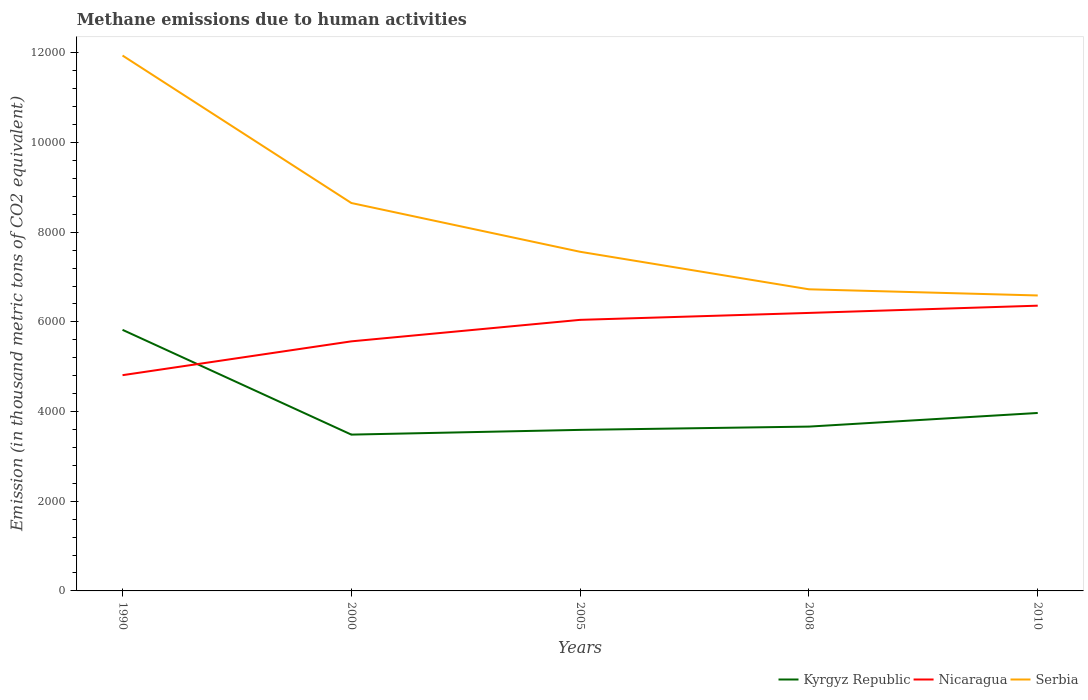How many different coloured lines are there?
Offer a very short reply. 3. Does the line corresponding to Nicaragua intersect with the line corresponding to Kyrgyz Republic?
Give a very brief answer. Yes. Across all years, what is the maximum amount of methane emitted in Nicaragua?
Provide a succinct answer. 4811.3. In which year was the amount of methane emitted in Serbia maximum?
Provide a succinct answer. 2010. What is the total amount of methane emitted in Serbia in the graph?
Your answer should be very brief. 836.6. What is the difference between the highest and the second highest amount of methane emitted in Nicaragua?
Your answer should be compact. 1550.1. What is the difference between the highest and the lowest amount of methane emitted in Nicaragua?
Provide a short and direct response. 3. How many years are there in the graph?
Your response must be concise. 5. Does the graph contain any zero values?
Your answer should be compact. No. Does the graph contain grids?
Your answer should be very brief. No. How many legend labels are there?
Your response must be concise. 3. What is the title of the graph?
Keep it short and to the point. Methane emissions due to human activities. What is the label or title of the X-axis?
Your answer should be very brief. Years. What is the label or title of the Y-axis?
Make the answer very short. Emission (in thousand metric tons of CO2 equivalent). What is the Emission (in thousand metric tons of CO2 equivalent) in Kyrgyz Republic in 1990?
Keep it short and to the point. 5822.6. What is the Emission (in thousand metric tons of CO2 equivalent) of Nicaragua in 1990?
Make the answer very short. 4811.3. What is the Emission (in thousand metric tons of CO2 equivalent) of Serbia in 1990?
Make the answer very short. 1.19e+04. What is the Emission (in thousand metric tons of CO2 equivalent) of Kyrgyz Republic in 2000?
Your answer should be compact. 3485.8. What is the Emission (in thousand metric tons of CO2 equivalent) in Nicaragua in 2000?
Give a very brief answer. 5565.7. What is the Emission (in thousand metric tons of CO2 equivalent) of Serbia in 2000?
Ensure brevity in your answer.  8650.9. What is the Emission (in thousand metric tons of CO2 equivalent) of Kyrgyz Republic in 2005?
Keep it short and to the point. 3591.3. What is the Emission (in thousand metric tons of CO2 equivalent) in Nicaragua in 2005?
Your answer should be very brief. 6045. What is the Emission (in thousand metric tons of CO2 equivalent) in Serbia in 2005?
Your response must be concise. 7563. What is the Emission (in thousand metric tons of CO2 equivalent) in Kyrgyz Republic in 2008?
Keep it short and to the point. 3664.5. What is the Emission (in thousand metric tons of CO2 equivalent) of Nicaragua in 2008?
Ensure brevity in your answer.  6199.5. What is the Emission (in thousand metric tons of CO2 equivalent) in Serbia in 2008?
Your answer should be very brief. 6726.4. What is the Emission (in thousand metric tons of CO2 equivalent) in Kyrgyz Republic in 2010?
Offer a very short reply. 3968.4. What is the Emission (in thousand metric tons of CO2 equivalent) of Nicaragua in 2010?
Give a very brief answer. 6361.4. What is the Emission (in thousand metric tons of CO2 equivalent) of Serbia in 2010?
Your answer should be very brief. 6589. Across all years, what is the maximum Emission (in thousand metric tons of CO2 equivalent) in Kyrgyz Republic?
Provide a short and direct response. 5822.6. Across all years, what is the maximum Emission (in thousand metric tons of CO2 equivalent) of Nicaragua?
Your answer should be very brief. 6361.4. Across all years, what is the maximum Emission (in thousand metric tons of CO2 equivalent) in Serbia?
Keep it short and to the point. 1.19e+04. Across all years, what is the minimum Emission (in thousand metric tons of CO2 equivalent) in Kyrgyz Republic?
Your response must be concise. 3485.8. Across all years, what is the minimum Emission (in thousand metric tons of CO2 equivalent) in Nicaragua?
Offer a very short reply. 4811.3. Across all years, what is the minimum Emission (in thousand metric tons of CO2 equivalent) of Serbia?
Make the answer very short. 6589. What is the total Emission (in thousand metric tons of CO2 equivalent) in Kyrgyz Republic in the graph?
Provide a short and direct response. 2.05e+04. What is the total Emission (in thousand metric tons of CO2 equivalent) of Nicaragua in the graph?
Your response must be concise. 2.90e+04. What is the total Emission (in thousand metric tons of CO2 equivalent) in Serbia in the graph?
Offer a terse response. 4.15e+04. What is the difference between the Emission (in thousand metric tons of CO2 equivalent) of Kyrgyz Republic in 1990 and that in 2000?
Provide a succinct answer. 2336.8. What is the difference between the Emission (in thousand metric tons of CO2 equivalent) in Nicaragua in 1990 and that in 2000?
Provide a short and direct response. -754.4. What is the difference between the Emission (in thousand metric tons of CO2 equivalent) of Serbia in 1990 and that in 2000?
Your response must be concise. 3288.8. What is the difference between the Emission (in thousand metric tons of CO2 equivalent) of Kyrgyz Republic in 1990 and that in 2005?
Your response must be concise. 2231.3. What is the difference between the Emission (in thousand metric tons of CO2 equivalent) of Nicaragua in 1990 and that in 2005?
Ensure brevity in your answer.  -1233.7. What is the difference between the Emission (in thousand metric tons of CO2 equivalent) in Serbia in 1990 and that in 2005?
Ensure brevity in your answer.  4376.7. What is the difference between the Emission (in thousand metric tons of CO2 equivalent) in Kyrgyz Republic in 1990 and that in 2008?
Your response must be concise. 2158.1. What is the difference between the Emission (in thousand metric tons of CO2 equivalent) of Nicaragua in 1990 and that in 2008?
Offer a terse response. -1388.2. What is the difference between the Emission (in thousand metric tons of CO2 equivalent) of Serbia in 1990 and that in 2008?
Offer a terse response. 5213.3. What is the difference between the Emission (in thousand metric tons of CO2 equivalent) of Kyrgyz Republic in 1990 and that in 2010?
Keep it short and to the point. 1854.2. What is the difference between the Emission (in thousand metric tons of CO2 equivalent) in Nicaragua in 1990 and that in 2010?
Provide a short and direct response. -1550.1. What is the difference between the Emission (in thousand metric tons of CO2 equivalent) of Serbia in 1990 and that in 2010?
Keep it short and to the point. 5350.7. What is the difference between the Emission (in thousand metric tons of CO2 equivalent) of Kyrgyz Republic in 2000 and that in 2005?
Offer a terse response. -105.5. What is the difference between the Emission (in thousand metric tons of CO2 equivalent) in Nicaragua in 2000 and that in 2005?
Keep it short and to the point. -479.3. What is the difference between the Emission (in thousand metric tons of CO2 equivalent) of Serbia in 2000 and that in 2005?
Your answer should be compact. 1087.9. What is the difference between the Emission (in thousand metric tons of CO2 equivalent) of Kyrgyz Republic in 2000 and that in 2008?
Offer a terse response. -178.7. What is the difference between the Emission (in thousand metric tons of CO2 equivalent) in Nicaragua in 2000 and that in 2008?
Offer a very short reply. -633.8. What is the difference between the Emission (in thousand metric tons of CO2 equivalent) of Serbia in 2000 and that in 2008?
Make the answer very short. 1924.5. What is the difference between the Emission (in thousand metric tons of CO2 equivalent) in Kyrgyz Republic in 2000 and that in 2010?
Keep it short and to the point. -482.6. What is the difference between the Emission (in thousand metric tons of CO2 equivalent) of Nicaragua in 2000 and that in 2010?
Your answer should be compact. -795.7. What is the difference between the Emission (in thousand metric tons of CO2 equivalent) in Serbia in 2000 and that in 2010?
Provide a succinct answer. 2061.9. What is the difference between the Emission (in thousand metric tons of CO2 equivalent) in Kyrgyz Republic in 2005 and that in 2008?
Provide a short and direct response. -73.2. What is the difference between the Emission (in thousand metric tons of CO2 equivalent) of Nicaragua in 2005 and that in 2008?
Your answer should be very brief. -154.5. What is the difference between the Emission (in thousand metric tons of CO2 equivalent) of Serbia in 2005 and that in 2008?
Provide a short and direct response. 836.6. What is the difference between the Emission (in thousand metric tons of CO2 equivalent) of Kyrgyz Republic in 2005 and that in 2010?
Provide a succinct answer. -377.1. What is the difference between the Emission (in thousand metric tons of CO2 equivalent) in Nicaragua in 2005 and that in 2010?
Give a very brief answer. -316.4. What is the difference between the Emission (in thousand metric tons of CO2 equivalent) of Serbia in 2005 and that in 2010?
Make the answer very short. 974. What is the difference between the Emission (in thousand metric tons of CO2 equivalent) in Kyrgyz Republic in 2008 and that in 2010?
Offer a terse response. -303.9. What is the difference between the Emission (in thousand metric tons of CO2 equivalent) in Nicaragua in 2008 and that in 2010?
Make the answer very short. -161.9. What is the difference between the Emission (in thousand metric tons of CO2 equivalent) in Serbia in 2008 and that in 2010?
Make the answer very short. 137.4. What is the difference between the Emission (in thousand metric tons of CO2 equivalent) in Kyrgyz Republic in 1990 and the Emission (in thousand metric tons of CO2 equivalent) in Nicaragua in 2000?
Offer a terse response. 256.9. What is the difference between the Emission (in thousand metric tons of CO2 equivalent) in Kyrgyz Republic in 1990 and the Emission (in thousand metric tons of CO2 equivalent) in Serbia in 2000?
Offer a very short reply. -2828.3. What is the difference between the Emission (in thousand metric tons of CO2 equivalent) of Nicaragua in 1990 and the Emission (in thousand metric tons of CO2 equivalent) of Serbia in 2000?
Your answer should be compact. -3839.6. What is the difference between the Emission (in thousand metric tons of CO2 equivalent) in Kyrgyz Republic in 1990 and the Emission (in thousand metric tons of CO2 equivalent) in Nicaragua in 2005?
Provide a succinct answer. -222.4. What is the difference between the Emission (in thousand metric tons of CO2 equivalent) in Kyrgyz Republic in 1990 and the Emission (in thousand metric tons of CO2 equivalent) in Serbia in 2005?
Make the answer very short. -1740.4. What is the difference between the Emission (in thousand metric tons of CO2 equivalent) in Nicaragua in 1990 and the Emission (in thousand metric tons of CO2 equivalent) in Serbia in 2005?
Make the answer very short. -2751.7. What is the difference between the Emission (in thousand metric tons of CO2 equivalent) of Kyrgyz Republic in 1990 and the Emission (in thousand metric tons of CO2 equivalent) of Nicaragua in 2008?
Your answer should be very brief. -376.9. What is the difference between the Emission (in thousand metric tons of CO2 equivalent) of Kyrgyz Republic in 1990 and the Emission (in thousand metric tons of CO2 equivalent) of Serbia in 2008?
Make the answer very short. -903.8. What is the difference between the Emission (in thousand metric tons of CO2 equivalent) in Nicaragua in 1990 and the Emission (in thousand metric tons of CO2 equivalent) in Serbia in 2008?
Your response must be concise. -1915.1. What is the difference between the Emission (in thousand metric tons of CO2 equivalent) of Kyrgyz Republic in 1990 and the Emission (in thousand metric tons of CO2 equivalent) of Nicaragua in 2010?
Your answer should be compact. -538.8. What is the difference between the Emission (in thousand metric tons of CO2 equivalent) in Kyrgyz Republic in 1990 and the Emission (in thousand metric tons of CO2 equivalent) in Serbia in 2010?
Make the answer very short. -766.4. What is the difference between the Emission (in thousand metric tons of CO2 equivalent) of Nicaragua in 1990 and the Emission (in thousand metric tons of CO2 equivalent) of Serbia in 2010?
Offer a terse response. -1777.7. What is the difference between the Emission (in thousand metric tons of CO2 equivalent) in Kyrgyz Republic in 2000 and the Emission (in thousand metric tons of CO2 equivalent) in Nicaragua in 2005?
Provide a succinct answer. -2559.2. What is the difference between the Emission (in thousand metric tons of CO2 equivalent) of Kyrgyz Republic in 2000 and the Emission (in thousand metric tons of CO2 equivalent) of Serbia in 2005?
Your response must be concise. -4077.2. What is the difference between the Emission (in thousand metric tons of CO2 equivalent) in Nicaragua in 2000 and the Emission (in thousand metric tons of CO2 equivalent) in Serbia in 2005?
Your response must be concise. -1997.3. What is the difference between the Emission (in thousand metric tons of CO2 equivalent) of Kyrgyz Republic in 2000 and the Emission (in thousand metric tons of CO2 equivalent) of Nicaragua in 2008?
Keep it short and to the point. -2713.7. What is the difference between the Emission (in thousand metric tons of CO2 equivalent) of Kyrgyz Republic in 2000 and the Emission (in thousand metric tons of CO2 equivalent) of Serbia in 2008?
Provide a succinct answer. -3240.6. What is the difference between the Emission (in thousand metric tons of CO2 equivalent) of Nicaragua in 2000 and the Emission (in thousand metric tons of CO2 equivalent) of Serbia in 2008?
Keep it short and to the point. -1160.7. What is the difference between the Emission (in thousand metric tons of CO2 equivalent) in Kyrgyz Republic in 2000 and the Emission (in thousand metric tons of CO2 equivalent) in Nicaragua in 2010?
Your answer should be compact. -2875.6. What is the difference between the Emission (in thousand metric tons of CO2 equivalent) of Kyrgyz Republic in 2000 and the Emission (in thousand metric tons of CO2 equivalent) of Serbia in 2010?
Give a very brief answer. -3103.2. What is the difference between the Emission (in thousand metric tons of CO2 equivalent) of Nicaragua in 2000 and the Emission (in thousand metric tons of CO2 equivalent) of Serbia in 2010?
Your answer should be very brief. -1023.3. What is the difference between the Emission (in thousand metric tons of CO2 equivalent) of Kyrgyz Republic in 2005 and the Emission (in thousand metric tons of CO2 equivalent) of Nicaragua in 2008?
Offer a very short reply. -2608.2. What is the difference between the Emission (in thousand metric tons of CO2 equivalent) in Kyrgyz Republic in 2005 and the Emission (in thousand metric tons of CO2 equivalent) in Serbia in 2008?
Ensure brevity in your answer.  -3135.1. What is the difference between the Emission (in thousand metric tons of CO2 equivalent) of Nicaragua in 2005 and the Emission (in thousand metric tons of CO2 equivalent) of Serbia in 2008?
Offer a very short reply. -681.4. What is the difference between the Emission (in thousand metric tons of CO2 equivalent) of Kyrgyz Republic in 2005 and the Emission (in thousand metric tons of CO2 equivalent) of Nicaragua in 2010?
Offer a terse response. -2770.1. What is the difference between the Emission (in thousand metric tons of CO2 equivalent) in Kyrgyz Republic in 2005 and the Emission (in thousand metric tons of CO2 equivalent) in Serbia in 2010?
Provide a succinct answer. -2997.7. What is the difference between the Emission (in thousand metric tons of CO2 equivalent) in Nicaragua in 2005 and the Emission (in thousand metric tons of CO2 equivalent) in Serbia in 2010?
Make the answer very short. -544. What is the difference between the Emission (in thousand metric tons of CO2 equivalent) in Kyrgyz Republic in 2008 and the Emission (in thousand metric tons of CO2 equivalent) in Nicaragua in 2010?
Your answer should be compact. -2696.9. What is the difference between the Emission (in thousand metric tons of CO2 equivalent) in Kyrgyz Republic in 2008 and the Emission (in thousand metric tons of CO2 equivalent) in Serbia in 2010?
Provide a short and direct response. -2924.5. What is the difference between the Emission (in thousand metric tons of CO2 equivalent) in Nicaragua in 2008 and the Emission (in thousand metric tons of CO2 equivalent) in Serbia in 2010?
Keep it short and to the point. -389.5. What is the average Emission (in thousand metric tons of CO2 equivalent) of Kyrgyz Republic per year?
Provide a short and direct response. 4106.52. What is the average Emission (in thousand metric tons of CO2 equivalent) of Nicaragua per year?
Give a very brief answer. 5796.58. What is the average Emission (in thousand metric tons of CO2 equivalent) in Serbia per year?
Make the answer very short. 8293.8. In the year 1990, what is the difference between the Emission (in thousand metric tons of CO2 equivalent) in Kyrgyz Republic and Emission (in thousand metric tons of CO2 equivalent) in Nicaragua?
Make the answer very short. 1011.3. In the year 1990, what is the difference between the Emission (in thousand metric tons of CO2 equivalent) in Kyrgyz Republic and Emission (in thousand metric tons of CO2 equivalent) in Serbia?
Give a very brief answer. -6117.1. In the year 1990, what is the difference between the Emission (in thousand metric tons of CO2 equivalent) of Nicaragua and Emission (in thousand metric tons of CO2 equivalent) of Serbia?
Offer a terse response. -7128.4. In the year 2000, what is the difference between the Emission (in thousand metric tons of CO2 equivalent) in Kyrgyz Republic and Emission (in thousand metric tons of CO2 equivalent) in Nicaragua?
Your answer should be very brief. -2079.9. In the year 2000, what is the difference between the Emission (in thousand metric tons of CO2 equivalent) of Kyrgyz Republic and Emission (in thousand metric tons of CO2 equivalent) of Serbia?
Provide a short and direct response. -5165.1. In the year 2000, what is the difference between the Emission (in thousand metric tons of CO2 equivalent) in Nicaragua and Emission (in thousand metric tons of CO2 equivalent) in Serbia?
Offer a very short reply. -3085.2. In the year 2005, what is the difference between the Emission (in thousand metric tons of CO2 equivalent) in Kyrgyz Republic and Emission (in thousand metric tons of CO2 equivalent) in Nicaragua?
Provide a short and direct response. -2453.7. In the year 2005, what is the difference between the Emission (in thousand metric tons of CO2 equivalent) in Kyrgyz Republic and Emission (in thousand metric tons of CO2 equivalent) in Serbia?
Provide a succinct answer. -3971.7. In the year 2005, what is the difference between the Emission (in thousand metric tons of CO2 equivalent) of Nicaragua and Emission (in thousand metric tons of CO2 equivalent) of Serbia?
Make the answer very short. -1518. In the year 2008, what is the difference between the Emission (in thousand metric tons of CO2 equivalent) of Kyrgyz Republic and Emission (in thousand metric tons of CO2 equivalent) of Nicaragua?
Offer a terse response. -2535. In the year 2008, what is the difference between the Emission (in thousand metric tons of CO2 equivalent) in Kyrgyz Republic and Emission (in thousand metric tons of CO2 equivalent) in Serbia?
Offer a terse response. -3061.9. In the year 2008, what is the difference between the Emission (in thousand metric tons of CO2 equivalent) in Nicaragua and Emission (in thousand metric tons of CO2 equivalent) in Serbia?
Your answer should be very brief. -526.9. In the year 2010, what is the difference between the Emission (in thousand metric tons of CO2 equivalent) of Kyrgyz Republic and Emission (in thousand metric tons of CO2 equivalent) of Nicaragua?
Provide a short and direct response. -2393. In the year 2010, what is the difference between the Emission (in thousand metric tons of CO2 equivalent) of Kyrgyz Republic and Emission (in thousand metric tons of CO2 equivalent) of Serbia?
Provide a short and direct response. -2620.6. In the year 2010, what is the difference between the Emission (in thousand metric tons of CO2 equivalent) of Nicaragua and Emission (in thousand metric tons of CO2 equivalent) of Serbia?
Your answer should be very brief. -227.6. What is the ratio of the Emission (in thousand metric tons of CO2 equivalent) in Kyrgyz Republic in 1990 to that in 2000?
Your answer should be very brief. 1.67. What is the ratio of the Emission (in thousand metric tons of CO2 equivalent) of Nicaragua in 1990 to that in 2000?
Make the answer very short. 0.86. What is the ratio of the Emission (in thousand metric tons of CO2 equivalent) in Serbia in 1990 to that in 2000?
Offer a very short reply. 1.38. What is the ratio of the Emission (in thousand metric tons of CO2 equivalent) in Kyrgyz Republic in 1990 to that in 2005?
Provide a succinct answer. 1.62. What is the ratio of the Emission (in thousand metric tons of CO2 equivalent) in Nicaragua in 1990 to that in 2005?
Your answer should be very brief. 0.8. What is the ratio of the Emission (in thousand metric tons of CO2 equivalent) of Serbia in 1990 to that in 2005?
Provide a short and direct response. 1.58. What is the ratio of the Emission (in thousand metric tons of CO2 equivalent) in Kyrgyz Republic in 1990 to that in 2008?
Your answer should be compact. 1.59. What is the ratio of the Emission (in thousand metric tons of CO2 equivalent) in Nicaragua in 1990 to that in 2008?
Keep it short and to the point. 0.78. What is the ratio of the Emission (in thousand metric tons of CO2 equivalent) of Serbia in 1990 to that in 2008?
Keep it short and to the point. 1.78. What is the ratio of the Emission (in thousand metric tons of CO2 equivalent) of Kyrgyz Republic in 1990 to that in 2010?
Offer a very short reply. 1.47. What is the ratio of the Emission (in thousand metric tons of CO2 equivalent) of Nicaragua in 1990 to that in 2010?
Ensure brevity in your answer.  0.76. What is the ratio of the Emission (in thousand metric tons of CO2 equivalent) of Serbia in 1990 to that in 2010?
Provide a short and direct response. 1.81. What is the ratio of the Emission (in thousand metric tons of CO2 equivalent) in Kyrgyz Republic in 2000 to that in 2005?
Give a very brief answer. 0.97. What is the ratio of the Emission (in thousand metric tons of CO2 equivalent) of Nicaragua in 2000 to that in 2005?
Offer a very short reply. 0.92. What is the ratio of the Emission (in thousand metric tons of CO2 equivalent) of Serbia in 2000 to that in 2005?
Provide a short and direct response. 1.14. What is the ratio of the Emission (in thousand metric tons of CO2 equivalent) in Kyrgyz Republic in 2000 to that in 2008?
Offer a very short reply. 0.95. What is the ratio of the Emission (in thousand metric tons of CO2 equivalent) of Nicaragua in 2000 to that in 2008?
Offer a terse response. 0.9. What is the ratio of the Emission (in thousand metric tons of CO2 equivalent) in Serbia in 2000 to that in 2008?
Give a very brief answer. 1.29. What is the ratio of the Emission (in thousand metric tons of CO2 equivalent) in Kyrgyz Republic in 2000 to that in 2010?
Your response must be concise. 0.88. What is the ratio of the Emission (in thousand metric tons of CO2 equivalent) in Nicaragua in 2000 to that in 2010?
Offer a very short reply. 0.87. What is the ratio of the Emission (in thousand metric tons of CO2 equivalent) of Serbia in 2000 to that in 2010?
Provide a short and direct response. 1.31. What is the ratio of the Emission (in thousand metric tons of CO2 equivalent) in Kyrgyz Republic in 2005 to that in 2008?
Your answer should be very brief. 0.98. What is the ratio of the Emission (in thousand metric tons of CO2 equivalent) of Nicaragua in 2005 to that in 2008?
Make the answer very short. 0.98. What is the ratio of the Emission (in thousand metric tons of CO2 equivalent) of Serbia in 2005 to that in 2008?
Your answer should be very brief. 1.12. What is the ratio of the Emission (in thousand metric tons of CO2 equivalent) of Kyrgyz Republic in 2005 to that in 2010?
Your response must be concise. 0.91. What is the ratio of the Emission (in thousand metric tons of CO2 equivalent) of Nicaragua in 2005 to that in 2010?
Your answer should be very brief. 0.95. What is the ratio of the Emission (in thousand metric tons of CO2 equivalent) of Serbia in 2005 to that in 2010?
Your answer should be very brief. 1.15. What is the ratio of the Emission (in thousand metric tons of CO2 equivalent) in Kyrgyz Republic in 2008 to that in 2010?
Your answer should be very brief. 0.92. What is the ratio of the Emission (in thousand metric tons of CO2 equivalent) in Nicaragua in 2008 to that in 2010?
Ensure brevity in your answer.  0.97. What is the ratio of the Emission (in thousand metric tons of CO2 equivalent) of Serbia in 2008 to that in 2010?
Provide a succinct answer. 1.02. What is the difference between the highest and the second highest Emission (in thousand metric tons of CO2 equivalent) in Kyrgyz Republic?
Offer a very short reply. 1854.2. What is the difference between the highest and the second highest Emission (in thousand metric tons of CO2 equivalent) of Nicaragua?
Your response must be concise. 161.9. What is the difference between the highest and the second highest Emission (in thousand metric tons of CO2 equivalent) of Serbia?
Give a very brief answer. 3288.8. What is the difference between the highest and the lowest Emission (in thousand metric tons of CO2 equivalent) in Kyrgyz Republic?
Your answer should be very brief. 2336.8. What is the difference between the highest and the lowest Emission (in thousand metric tons of CO2 equivalent) of Nicaragua?
Provide a short and direct response. 1550.1. What is the difference between the highest and the lowest Emission (in thousand metric tons of CO2 equivalent) of Serbia?
Provide a short and direct response. 5350.7. 